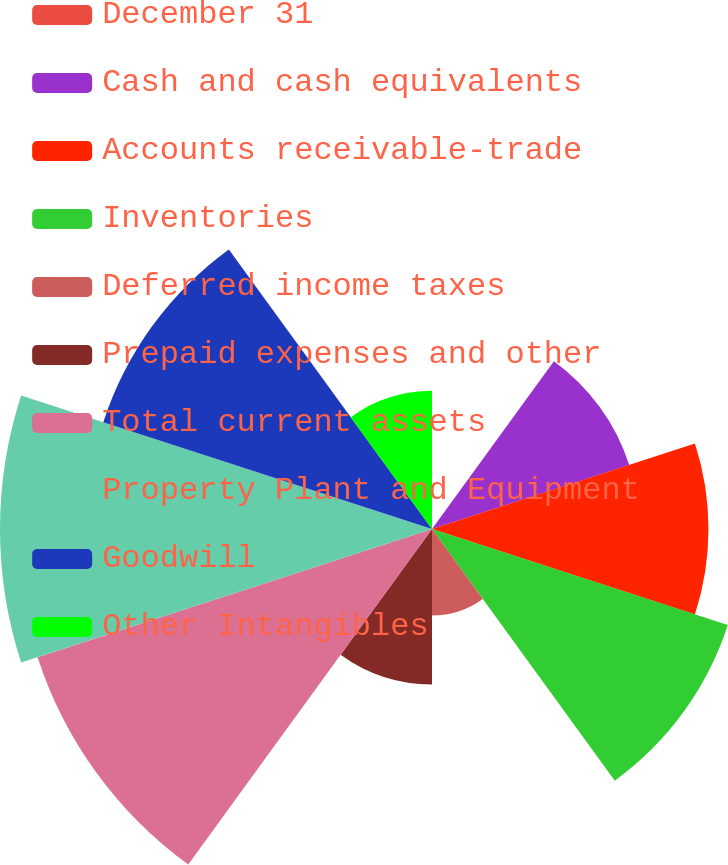<chart> <loc_0><loc_0><loc_500><loc_500><pie_chart><fcel>December 31<fcel>Cash and cash equivalents<fcel>Accounts receivable-trade<fcel>Inventories<fcel>Deferred income taxes<fcel>Prepaid expenses and other<fcel>Total current assets<fcel>Property Plant and Equipment<fcel>Goodwill<fcel>Other Intangibles<nl><fcel>0.0%<fcel>8.76%<fcel>11.68%<fcel>13.14%<fcel>3.65%<fcel>6.57%<fcel>17.52%<fcel>18.25%<fcel>14.6%<fcel>5.84%<nl></chart> 